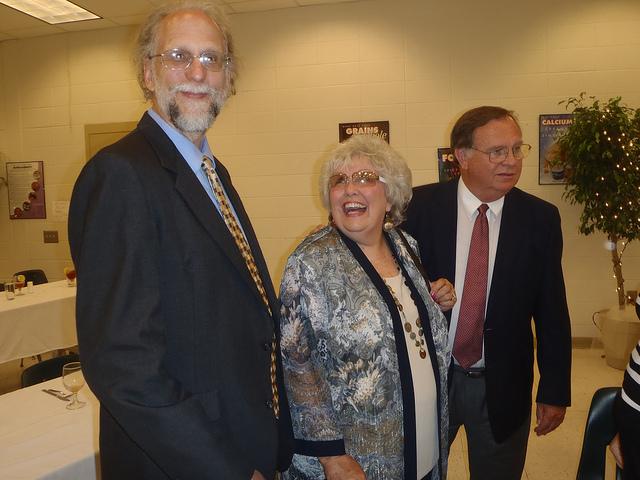What color is his suit jacket?
Short answer required. Black. What machine is on the desk?
Quick response, please. None. What is the boy and girl doing?
Concise answer only. Smiling. What was the presentation about?
Give a very brief answer. Business. Are these two people a couple?
Quick response, please. Yes. Is the woman happy?
Keep it brief. Yes. What color is the tie of the man on the left?
Give a very brief answer. Yellow. Who is the tallest person?
Be succinct. Man on left. Which outfit matches better?
Write a very short answer. Man on left. How many men do you see?
Write a very short answer. 2. How many people are wearing glasses?
Concise answer only. 3. How many men?
Be succinct. 2. What is the color of the tie seen?
Short answer required. Red. Is everyone wearing glasses?
Write a very short answer. Yes. What is the likely occupation of the man furthest in the background?
Keep it brief. Banker. Is one of these women wearing glasses?
Quick response, please. Yes. What pattern is the woman's dress?
Answer briefly. Floral. Who is the man on the left?
Keep it brief. Husband. Are these two men on the television?
Answer briefly. No. Do these people look happy?
Be succinct. Yes. Are both men looking the same direction?
Write a very short answer. No. Does the man wearing glasses have a beard or mustache?
Concise answer only. Both. Is this a celebration?
Short answer required. Yes. What color is the man's hair?
Answer briefly. Gray. Are all of the people wearing glasses?
Be succinct. Yes. Is it the 50th birthday of the man with the red tie?
Quick response, please. No. Where are they?
Quick response, please. Inside. What kind of coat is the woman wearing?
Give a very brief answer. Silk. 